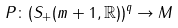Convert formula to latex. <formula><loc_0><loc_0><loc_500><loc_500>P \colon ( { S _ { + } ( m + 1 , \mathbb { R } ) } ) ^ { q } \rightarrow M</formula> 